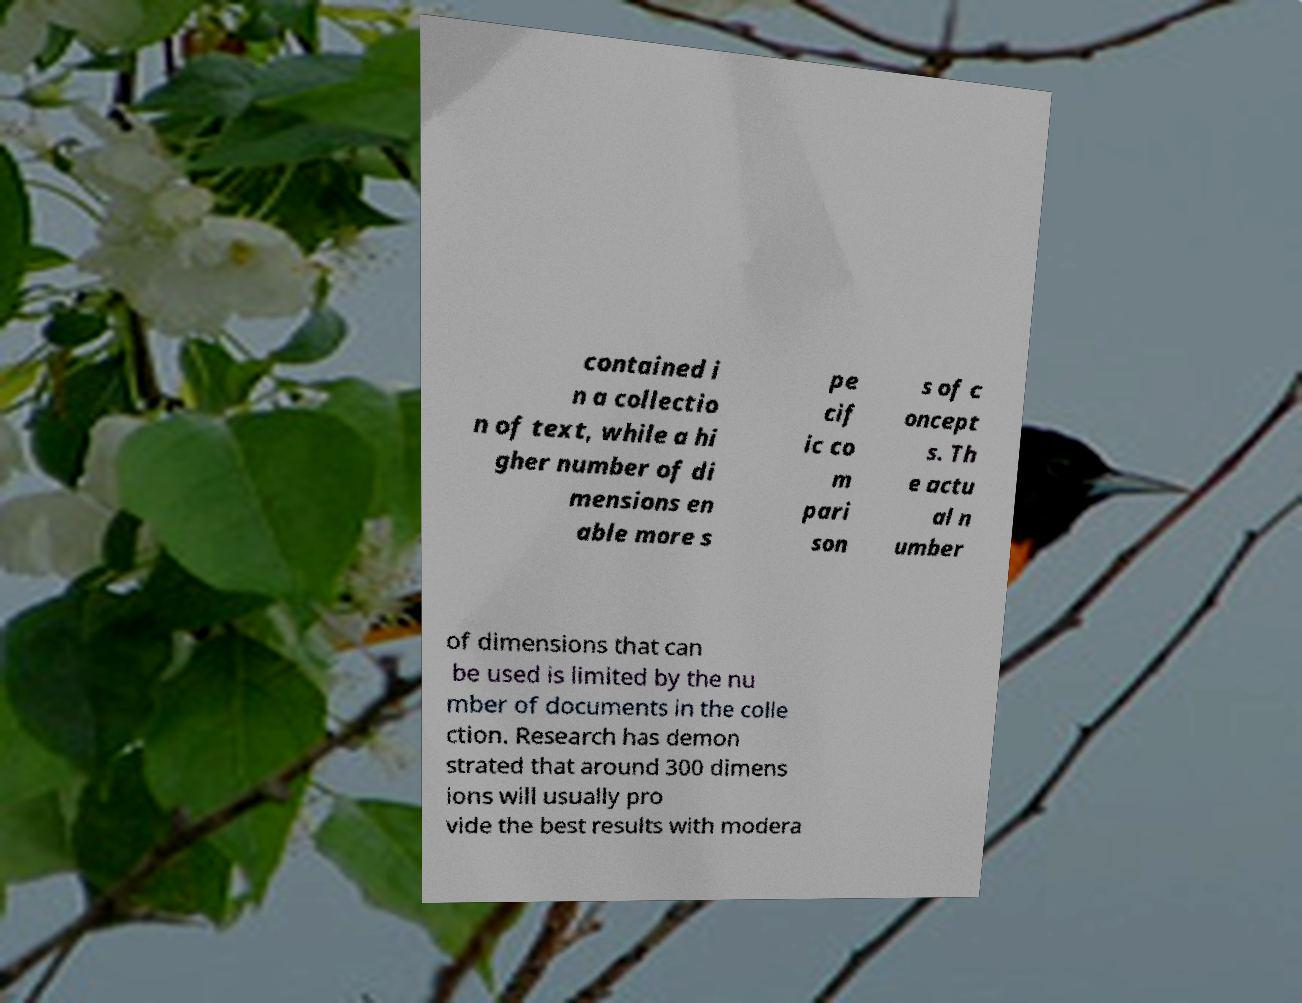What messages or text are displayed in this image? I need them in a readable, typed format. contained i n a collectio n of text, while a hi gher number of di mensions en able more s pe cif ic co m pari son s of c oncept s. Th e actu al n umber of dimensions that can be used is limited by the nu mber of documents in the colle ction. Research has demon strated that around 300 dimens ions will usually pro vide the best results with modera 